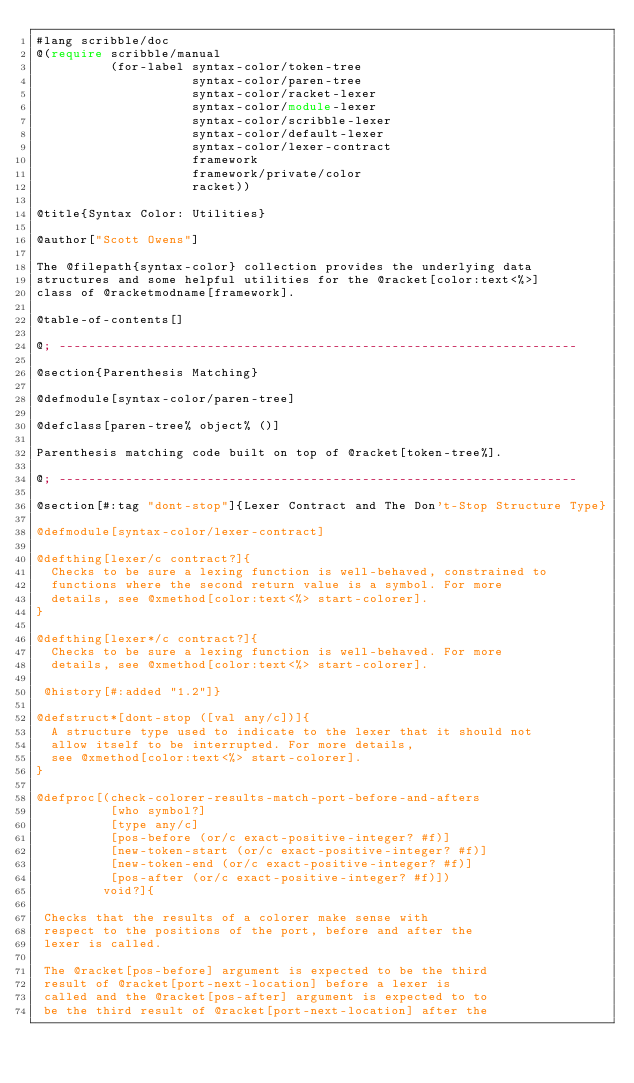<code> <loc_0><loc_0><loc_500><loc_500><_Racket_>#lang scribble/doc
@(require scribble/manual
          (for-label syntax-color/token-tree
                     syntax-color/paren-tree
                     syntax-color/racket-lexer
                     syntax-color/module-lexer
                     syntax-color/scribble-lexer
                     syntax-color/default-lexer
                     syntax-color/lexer-contract
                     framework
                     framework/private/color
                     racket))

@title{Syntax Color: Utilities}

@author["Scott Owens"]

The @filepath{syntax-color} collection provides the underlying data
structures and some helpful utilities for the @racket[color:text<%>]
class of @racketmodname[framework].

@table-of-contents[]

@; ----------------------------------------------------------------------

@section{Parenthesis Matching}

@defmodule[syntax-color/paren-tree]

@defclass[paren-tree% object% ()]

Parenthesis matching code built on top of @racket[token-tree%].

@; ----------------------------------------------------------------------

@section[#:tag "dont-stop"]{Lexer Contract and The Don't-Stop Structure Type}

@defmodule[syntax-color/lexer-contract]

@defthing[lexer/c contract?]{
  Checks to be sure a lexing function is well-behaved, constrained to
  functions where the second return value is a symbol. For more
  details, see @xmethod[color:text<%> start-colorer].
}

@defthing[lexer*/c contract?]{
  Checks to be sure a lexing function is well-behaved. For more
  details, see @xmethod[color:text<%> start-colorer].

 @history[#:added "1.2"]}

@defstruct*[dont-stop ([val any/c])]{
  A structure type used to indicate to the lexer that it should not
  allow itself to be interrupted. For more details,
  see @xmethod[color:text<%> start-colorer].
}

@defproc[(check-colorer-results-match-port-before-and-afters
          [who symbol?]
          [type any/c]
          [pos-before (or/c exact-positive-integer? #f)]
          [new-token-start (or/c exact-positive-integer? #f)]
          [new-token-end (or/c exact-positive-integer? #f)]
          [pos-after (or/c exact-positive-integer? #f)])
         void?]{

 Checks that the results of a colorer make sense with
 respect to the positions of the port, before and after the
 lexer is called.

 The @racket[pos-before] argument is expected to be the third
 result of @racket[port-next-location] before a lexer is
 called and the @racket[pos-after] argument is expected to to
 be the third result of @racket[port-next-location] after the</code> 